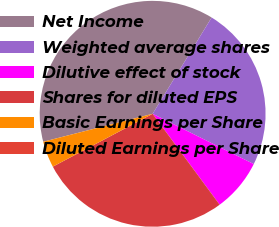<chart> <loc_0><loc_0><loc_500><loc_500><pie_chart><fcel>Net Income<fcel>Weighted average shares<fcel>Dilutive effect of stock<fcel>Shares for diluted EPS<fcel>Basic Earnings per Share<fcel>Diluted Earnings per Share<nl><fcel>37.73%<fcel>23.59%<fcel>7.55%<fcel>27.36%<fcel>3.77%<fcel>0.0%<nl></chart> 